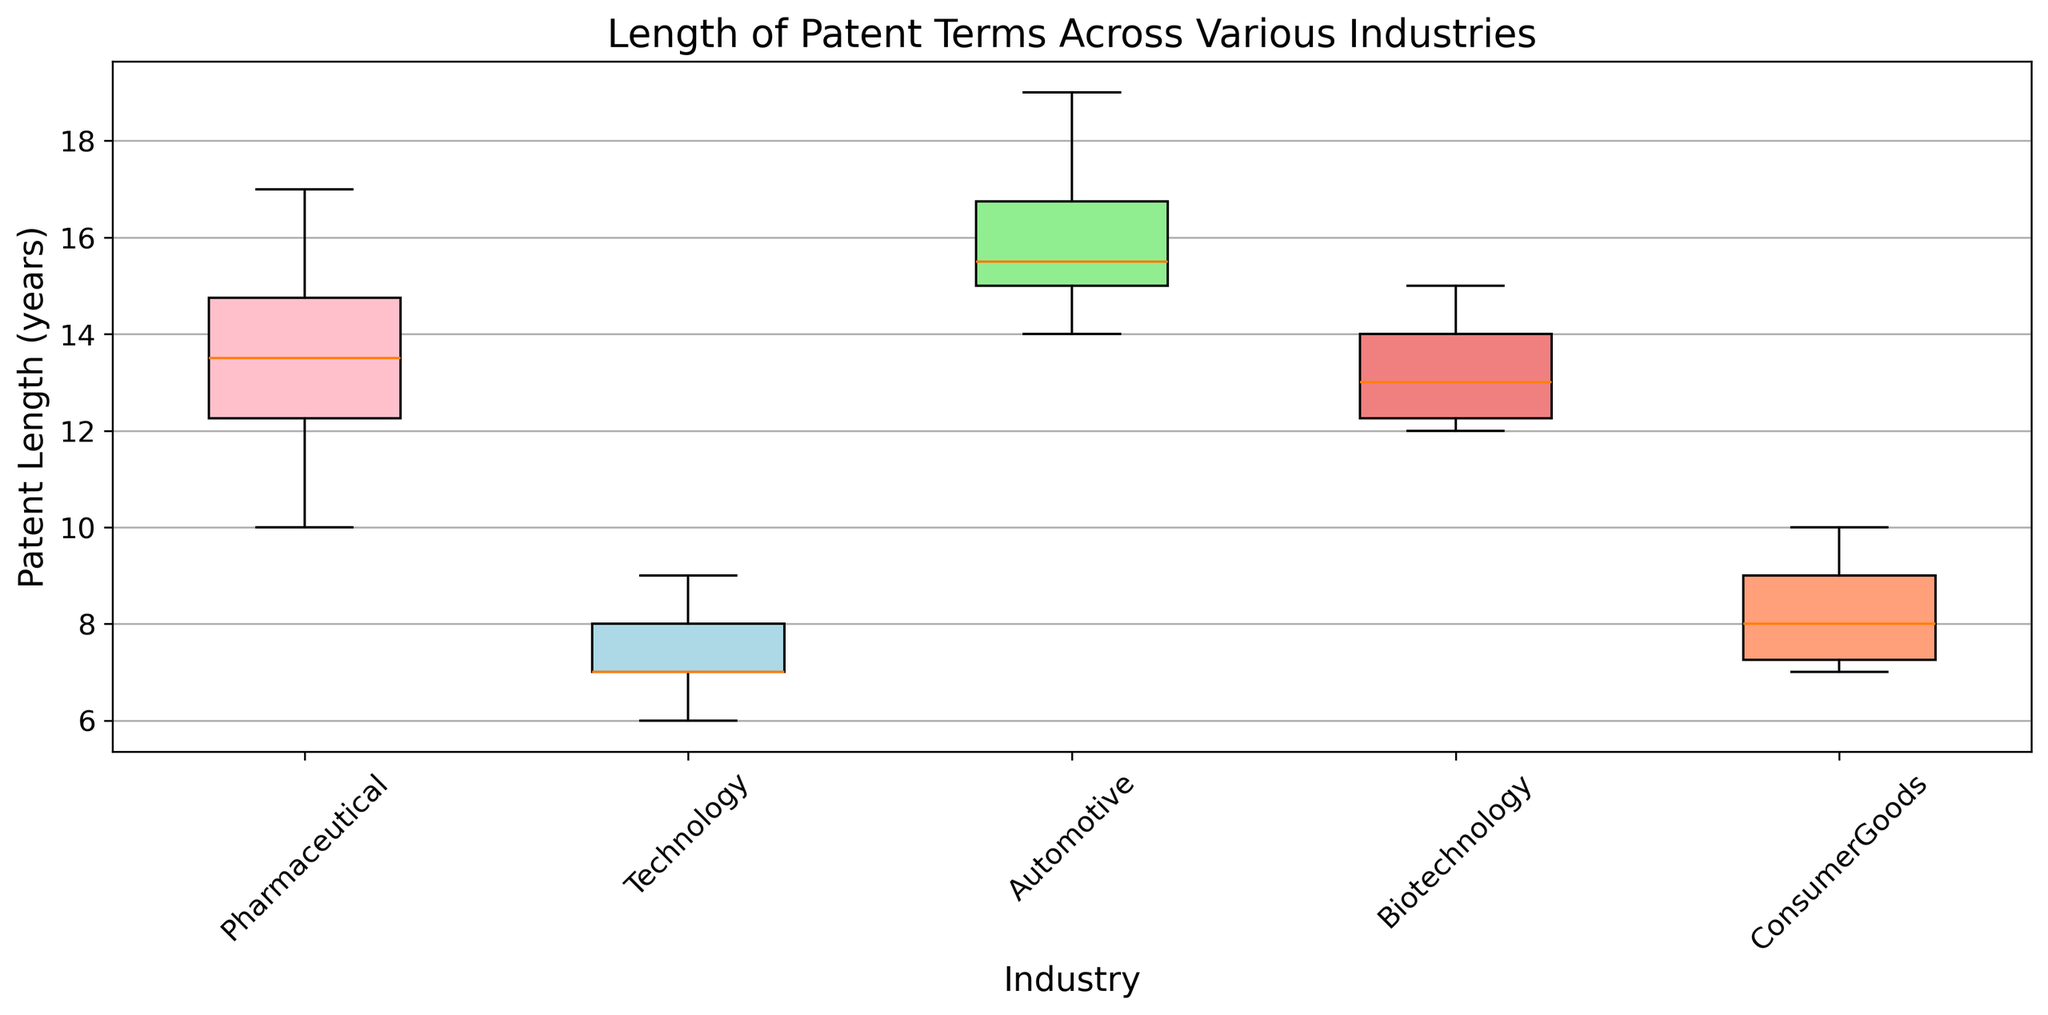What's the median patent length for the Pharmaceutical industry? The median is the middle value when the data points are ordered. For the Pharmaceutical industry, the ordered patent lengths are: [10, 11, 12, 13, 13, 14, 14, 15, 16, 17]. The median is the average of the two middle values: (13 + 14) / 2 = 13.5
Answer: 13.5 Which industry has the highest median patent length? Compare the medians of each industry. Pharmaceuticals: 13.5, Technology: 7, Automotive: 15.5, Biotechnology: 13, ConsumerGoods: 8. Automotive has the highest median patent length.
Answer: Automotive Which industry has the smallest range in patent lengths? Calculate the range (max - min) for each industry. Pharmaceuticals: 17-10=7, Technology: 9-6=3, Automotive: 19-14=5, Biotechnology: 15-12=3, ConsumerGoods: 10-7=3. Three industries have a range of 3, but the question is asking for the smallest, any of these would be correct.
Answer: Technology/Biotechnology/ConsumerGoods Does any industry have an outlier according to the boxplot? Check the boxplot for points outside of the whiskers, representing outliers. No outliers are visible in the figure.
Answer: No How does the interquartile range (IQR) for the Technology industry compare to the ConsumerGoods industry? The IQR is the difference between Q3 and Q1. For Technology (Q3=8, Q1=7): IQR=1. For ConsumerGoods (Q3=9, Q1=7): IQR=2.
Answer: The Technology industry's IQR is smaller than the ConsumerGoods industry's IQR What is the range of the interquartile ranges (IQRs) for all industries? First calculate the IQR for each industry: Pharma: 15-12=3, Tech: 8-7=1, Auto: 17-15=2, Biotech: 14-12=2, ConsumerGoods: 9-7=2. The range of these values is max IQR - min IQR: 3 - 1 = 2.
Answer: 2 